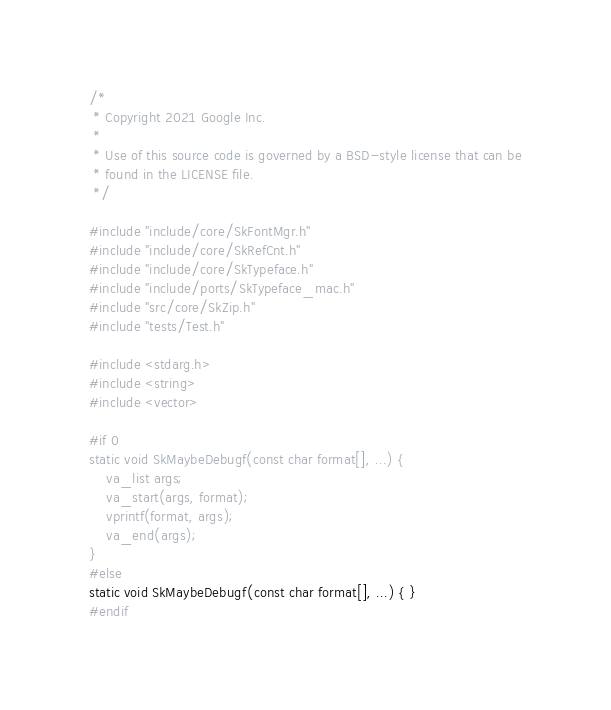Convert code to text. <code><loc_0><loc_0><loc_500><loc_500><_C++_>/*
 * Copyright 2021 Google Inc.
 *
 * Use of this source code is governed by a BSD-style license that can be
 * found in the LICENSE file.
 */

#include "include/core/SkFontMgr.h"
#include "include/core/SkRefCnt.h"
#include "include/core/SkTypeface.h"
#include "include/ports/SkTypeface_mac.h"
#include "src/core/SkZip.h"
#include "tests/Test.h"

#include <stdarg.h>
#include <string>
#include <vector>

#if 0
static void SkMaybeDebugf(const char format[], ...) {
    va_list args;
    va_start(args, format);
    vprintf(format, args);
    va_end(args);
}
#else
static void SkMaybeDebugf(const char format[], ...) { }
#endif
</code> 